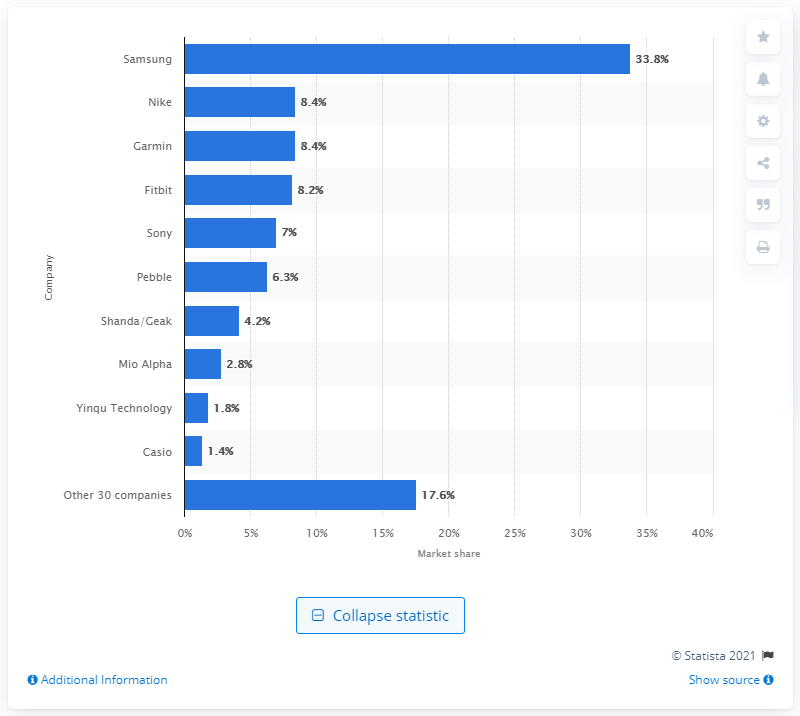Indicate a few pertinent items in this graphic. In 2013, Samsung was the leading smartwatch company. Samsung's market share in 2013 was 33.8%. 